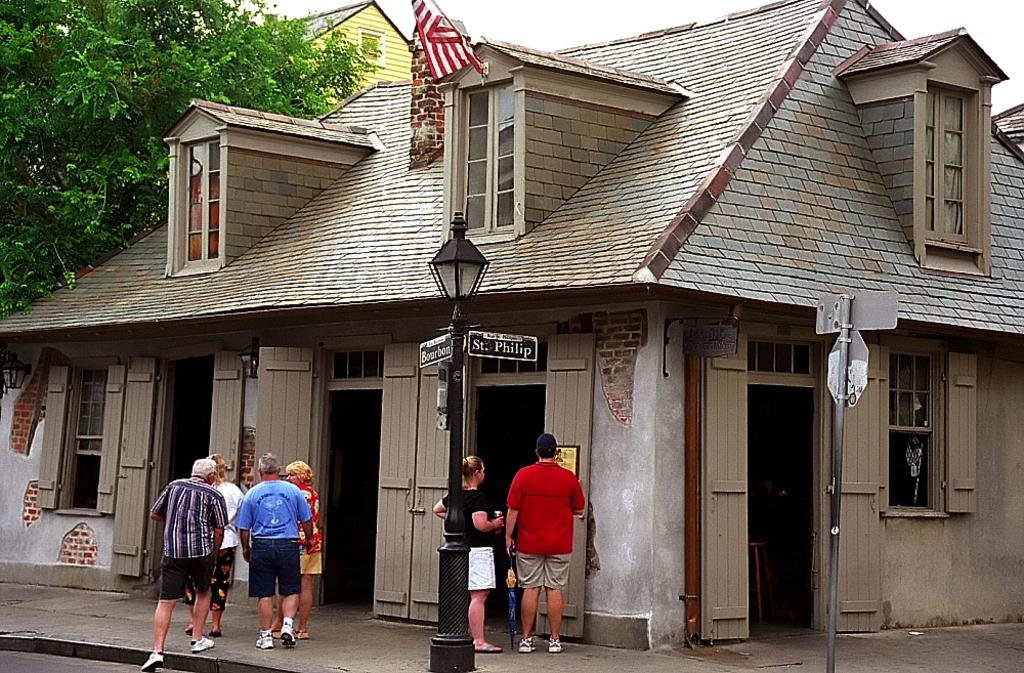What are the people in the image doing? The persons standing on the floor are likely walking or standing still. What structures can be seen in the image? Street poles, street lights, sign boards, and a building are visible in the image. What type of vegetation is present in the image? Trees are present in the image. What part of the natural environment is visible in the image? The sky is visible in the image. Can you tell me how deep the water is where the persons are swimming in the image? There is no water or swimming depicted in the image; the persons are standing on the floor. 